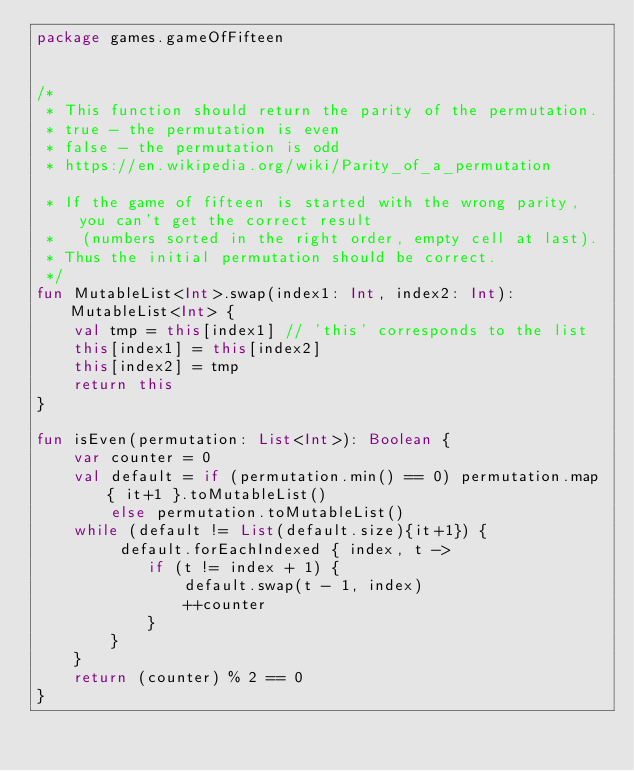Convert code to text. <code><loc_0><loc_0><loc_500><loc_500><_Kotlin_>package games.gameOfFifteen


/*
 * This function should return the parity of the permutation.
 * true - the permutation is even
 * false - the permutation is odd
 * https://en.wikipedia.org/wiki/Parity_of_a_permutation

 * If the game of fifteen is started with the wrong parity, you can't get the correct result
 *   (numbers sorted in the right order, empty cell at last).
 * Thus the initial permutation should be correct.
 */
fun MutableList<Int>.swap(index1: Int, index2: Int): MutableList<Int> {
    val tmp = this[index1] // 'this' corresponds to the list
    this[index1] = this[index2]
    this[index2] = tmp
    return this
}

fun isEven(permutation: List<Int>): Boolean {
    var counter = 0
    val default = if (permutation.min() == 0) permutation.map { it+1 }.toMutableList()
        else permutation.toMutableList()
    while (default != List(default.size){it+1}) {
         default.forEachIndexed { index, t ->
            if (t != index + 1) {
                default.swap(t - 1, index)
                ++counter
            }
        }
    }
    return (counter) % 2 == 0
}
</code> 